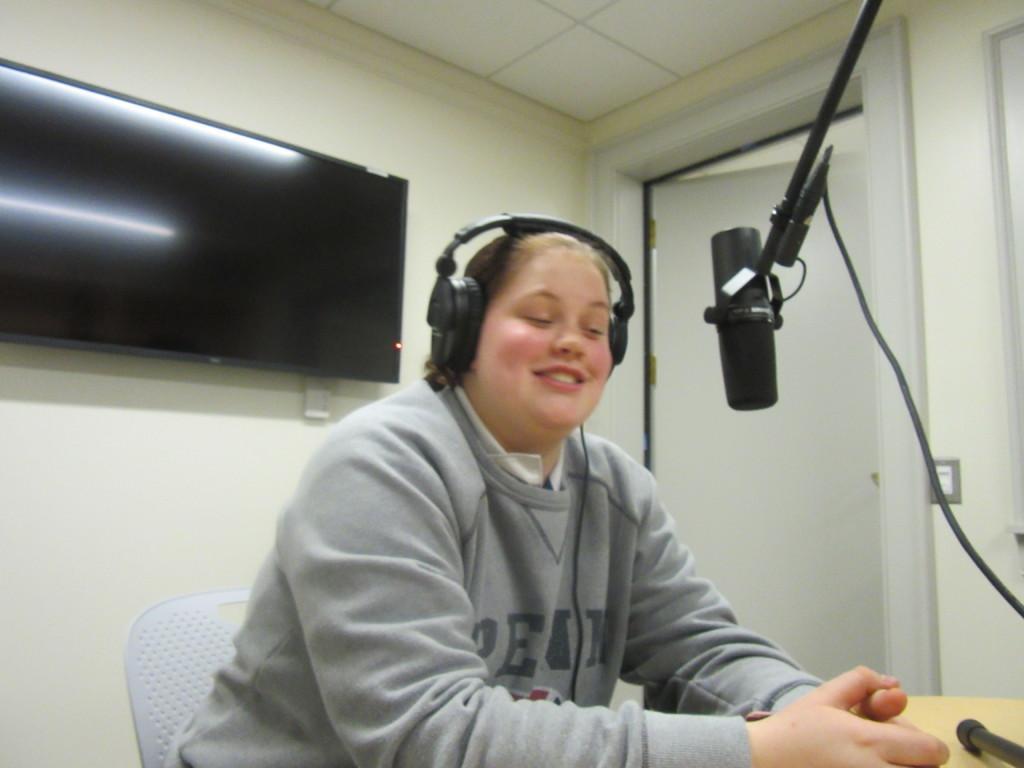Please provide a concise description of this image. In this image there is a woman sitting in a chair is wearing headphones, in front of the woman there is a mic with a cable and a stand on the table, behind the woman there is a wall mounted television on the wall and beside the television there is an open wooden door, beside the door there is a switch. 